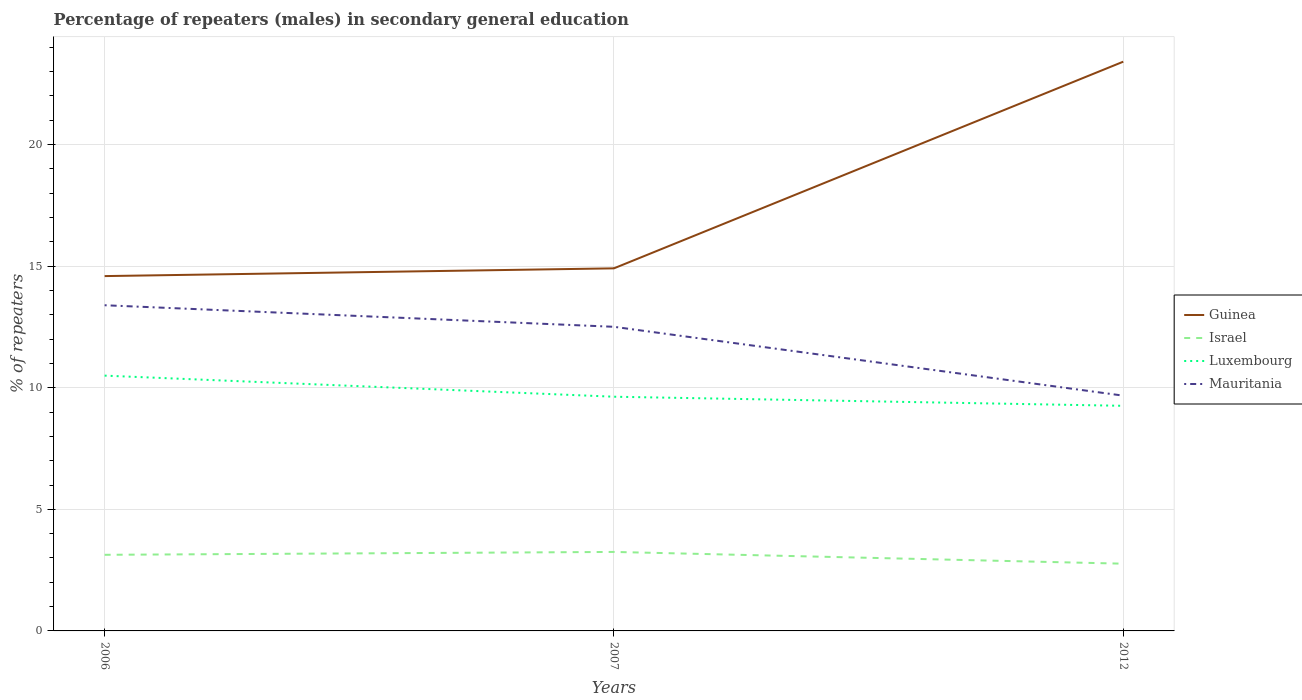Does the line corresponding to Guinea intersect with the line corresponding to Luxembourg?
Give a very brief answer. No. Is the number of lines equal to the number of legend labels?
Offer a terse response. Yes. Across all years, what is the maximum percentage of male repeaters in Luxembourg?
Your answer should be very brief. 9.26. What is the total percentage of male repeaters in Israel in the graph?
Offer a terse response. 0.36. What is the difference between the highest and the second highest percentage of male repeaters in Luxembourg?
Offer a very short reply. 1.24. What is the difference between the highest and the lowest percentage of male repeaters in Israel?
Your answer should be compact. 2. How many years are there in the graph?
Keep it short and to the point. 3. What is the difference between two consecutive major ticks on the Y-axis?
Your answer should be compact. 5. Are the values on the major ticks of Y-axis written in scientific E-notation?
Offer a very short reply. No. Does the graph contain any zero values?
Your response must be concise. No. How many legend labels are there?
Keep it short and to the point. 4. How are the legend labels stacked?
Offer a terse response. Vertical. What is the title of the graph?
Make the answer very short. Percentage of repeaters (males) in secondary general education. Does "Fragile and conflict affected situations" appear as one of the legend labels in the graph?
Your response must be concise. No. What is the label or title of the Y-axis?
Your answer should be compact. % of repeaters. What is the % of repeaters of Guinea in 2006?
Give a very brief answer. 14.59. What is the % of repeaters in Israel in 2006?
Provide a short and direct response. 3.13. What is the % of repeaters in Luxembourg in 2006?
Your answer should be compact. 10.5. What is the % of repeaters in Mauritania in 2006?
Your answer should be very brief. 13.39. What is the % of repeaters of Guinea in 2007?
Make the answer very short. 14.91. What is the % of repeaters of Israel in 2007?
Your answer should be compact. 3.25. What is the % of repeaters of Luxembourg in 2007?
Your answer should be compact. 9.63. What is the % of repeaters in Mauritania in 2007?
Offer a terse response. 12.51. What is the % of repeaters in Guinea in 2012?
Provide a succinct answer. 23.41. What is the % of repeaters in Israel in 2012?
Offer a terse response. 2.77. What is the % of repeaters in Luxembourg in 2012?
Provide a short and direct response. 9.26. What is the % of repeaters of Mauritania in 2012?
Ensure brevity in your answer.  9.68. Across all years, what is the maximum % of repeaters of Guinea?
Provide a succinct answer. 23.41. Across all years, what is the maximum % of repeaters of Israel?
Ensure brevity in your answer.  3.25. Across all years, what is the maximum % of repeaters of Luxembourg?
Keep it short and to the point. 10.5. Across all years, what is the maximum % of repeaters in Mauritania?
Provide a succinct answer. 13.39. Across all years, what is the minimum % of repeaters of Guinea?
Provide a short and direct response. 14.59. Across all years, what is the minimum % of repeaters of Israel?
Offer a terse response. 2.77. Across all years, what is the minimum % of repeaters in Luxembourg?
Offer a very short reply. 9.26. Across all years, what is the minimum % of repeaters of Mauritania?
Your answer should be very brief. 9.68. What is the total % of repeaters of Guinea in the graph?
Offer a terse response. 52.91. What is the total % of repeaters of Israel in the graph?
Your answer should be compact. 9.14. What is the total % of repeaters in Luxembourg in the graph?
Keep it short and to the point. 29.39. What is the total % of repeaters of Mauritania in the graph?
Your response must be concise. 35.58. What is the difference between the % of repeaters in Guinea in 2006 and that in 2007?
Keep it short and to the point. -0.32. What is the difference between the % of repeaters of Israel in 2006 and that in 2007?
Keep it short and to the point. -0.12. What is the difference between the % of repeaters in Luxembourg in 2006 and that in 2007?
Make the answer very short. 0.87. What is the difference between the % of repeaters in Mauritania in 2006 and that in 2007?
Provide a succinct answer. 0.89. What is the difference between the % of repeaters in Guinea in 2006 and that in 2012?
Offer a terse response. -8.82. What is the difference between the % of repeaters in Israel in 2006 and that in 2012?
Offer a terse response. 0.36. What is the difference between the % of repeaters in Luxembourg in 2006 and that in 2012?
Offer a very short reply. 1.24. What is the difference between the % of repeaters in Mauritania in 2006 and that in 2012?
Make the answer very short. 3.72. What is the difference between the % of repeaters in Guinea in 2007 and that in 2012?
Keep it short and to the point. -8.5. What is the difference between the % of repeaters in Israel in 2007 and that in 2012?
Provide a succinct answer. 0.48. What is the difference between the % of repeaters of Luxembourg in 2007 and that in 2012?
Give a very brief answer. 0.37. What is the difference between the % of repeaters of Mauritania in 2007 and that in 2012?
Make the answer very short. 2.83. What is the difference between the % of repeaters in Guinea in 2006 and the % of repeaters in Israel in 2007?
Offer a very short reply. 11.34. What is the difference between the % of repeaters of Guinea in 2006 and the % of repeaters of Luxembourg in 2007?
Your response must be concise. 4.96. What is the difference between the % of repeaters in Guinea in 2006 and the % of repeaters in Mauritania in 2007?
Ensure brevity in your answer.  2.09. What is the difference between the % of repeaters in Israel in 2006 and the % of repeaters in Luxembourg in 2007?
Give a very brief answer. -6.5. What is the difference between the % of repeaters of Israel in 2006 and the % of repeaters of Mauritania in 2007?
Offer a terse response. -9.38. What is the difference between the % of repeaters of Luxembourg in 2006 and the % of repeaters of Mauritania in 2007?
Offer a very short reply. -2.01. What is the difference between the % of repeaters in Guinea in 2006 and the % of repeaters in Israel in 2012?
Provide a succinct answer. 11.83. What is the difference between the % of repeaters of Guinea in 2006 and the % of repeaters of Luxembourg in 2012?
Offer a terse response. 5.33. What is the difference between the % of repeaters of Guinea in 2006 and the % of repeaters of Mauritania in 2012?
Give a very brief answer. 4.92. What is the difference between the % of repeaters in Israel in 2006 and the % of repeaters in Luxembourg in 2012?
Give a very brief answer. -6.13. What is the difference between the % of repeaters in Israel in 2006 and the % of repeaters in Mauritania in 2012?
Provide a short and direct response. -6.55. What is the difference between the % of repeaters in Luxembourg in 2006 and the % of repeaters in Mauritania in 2012?
Ensure brevity in your answer.  0.82. What is the difference between the % of repeaters of Guinea in 2007 and the % of repeaters of Israel in 2012?
Ensure brevity in your answer.  12.15. What is the difference between the % of repeaters in Guinea in 2007 and the % of repeaters in Luxembourg in 2012?
Your answer should be very brief. 5.65. What is the difference between the % of repeaters of Guinea in 2007 and the % of repeaters of Mauritania in 2012?
Ensure brevity in your answer.  5.24. What is the difference between the % of repeaters in Israel in 2007 and the % of repeaters in Luxembourg in 2012?
Make the answer very short. -6.01. What is the difference between the % of repeaters of Israel in 2007 and the % of repeaters of Mauritania in 2012?
Your response must be concise. -6.43. What is the difference between the % of repeaters in Luxembourg in 2007 and the % of repeaters in Mauritania in 2012?
Provide a short and direct response. -0.04. What is the average % of repeaters of Guinea per year?
Your answer should be compact. 17.64. What is the average % of repeaters of Israel per year?
Provide a short and direct response. 3.05. What is the average % of repeaters of Luxembourg per year?
Your answer should be very brief. 9.8. What is the average % of repeaters in Mauritania per year?
Keep it short and to the point. 11.86. In the year 2006, what is the difference between the % of repeaters of Guinea and % of repeaters of Israel?
Offer a very short reply. 11.46. In the year 2006, what is the difference between the % of repeaters of Guinea and % of repeaters of Luxembourg?
Provide a short and direct response. 4.09. In the year 2006, what is the difference between the % of repeaters in Guinea and % of repeaters in Mauritania?
Give a very brief answer. 1.2. In the year 2006, what is the difference between the % of repeaters of Israel and % of repeaters of Luxembourg?
Provide a succinct answer. -7.37. In the year 2006, what is the difference between the % of repeaters of Israel and % of repeaters of Mauritania?
Provide a succinct answer. -10.26. In the year 2006, what is the difference between the % of repeaters in Luxembourg and % of repeaters in Mauritania?
Offer a very short reply. -2.89. In the year 2007, what is the difference between the % of repeaters of Guinea and % of repeaters of Israel?
Provide a short and direct response. 11.66. In the year 2007, what is the difference between the % of repeaters of Guinea and % of repeaters of Luxembourg?
Your answer should be compact. 5.28. In the year 2007, what is the difference between the % of repeaters of Guinea and % of repeaters of Mauritania?
Ensure brevity in your answer.  2.4. In the year 2007, what is the difference between the % of repeaters in Israel and % of repeaters in Luxembourg?
Give a very brief answer. -6.38. In the year 2007, what is the difference between the % of repeaters of Israel and % of repeaters of Mauritania?
Keep it short and to the point. -9.26. In the year 2007, what is the difference between the % of repeaters of Luxembourg and % of repeaters of Mauritania?
Your response must be concise. -2.88. In the year 2012, what is the difference between the % of repeaters of Guinea and % of repeaters of Israel?
Make the answer very short. 20.65. In the year 2012, what is the difference between the % of repeaters of Guinea and % of repeaters of Luxembourg?
Offer a very short reply. 14.15. In the year 2012, what is the difference between the % of repeaters of Guinea and % of repeaters of Mauritania?
Your response must be concise. 13.73. In the year 2012, what is the difference between the % of repeaters in Israel and % of repeaters in Luxembourg?
Keep it short and to the point. -6.49. In the year 2012, what is the difference between the % of repeaters of Israel and % of repeaters of Mauritania?
Offer a very short reply. -6.91. In the year 2012, what is the difference between the % of repeaters in Luxembourg and % of repeaters in Mauritania?
Offer a terse response. -0.42. What is the ratio of the % of repeaters of Guinea in 2006 to that in 2007?
Your answer should be very brief. 0.98. What is the ratio of the % of repeaters of Israel in 2006 to that in 2007?
Provide a succinct answer. 0.96. What is the ratio of the % of repeaters of Luxembourg in 2006 to that in 2007?
Provide a short and direct response. 1.09. What is the ratio of the % of repeaters in Mauritania in 2006 to that in 2007?
Your response must be concise. 1.07. What is the ratio of the % of repeaters in Guinea in 2006 to that in 2012?
Your answer should be very brief. 0.62. What is the ratio of the % of repeaters of Israel in 2006 to that in 2012?
Ensure brevity in your answer.  1.13. What is the ratio of the % of repeaters in Luxembourg in 2006 to that in 2012?
Offer a very short reply. 1.13. What is the ratio of the % of repeaters of Mauritania in 2006 to that in 2012?
Provide a succinct answer. 1.38. What is the ratio of the % of repeaters of Guinea in 2007 to that in 2012?
Your response must be concise. 0.64. What is the ratio of the % of repeaters in Israel in 2007 to that in 2012?
Your answer should be compact. 1.17. What is the ratio of the % of repeaters of Luxembourg in 2007 to that in 2012?
Offer a terse response. 1.04. What is the ratio of the % of repeaters of Mauritania in 2007 to that in 2012?
Make the answer very short. 1.29. What is the difference between the highest and the second highest % of repeaters of Guinea?
Offer a terse response. 8.5. What is the difference between the highest and the second highest % of repeaters of Israel?
Give a very brief answer. 0.12. What is the difference between the highest and the second highest % of repeaters of Luxembourg?
Provide a short and direct response. 0.87. What is the difference between the highest and the second highest % of repeaters in Mauritania?
Provide a succinct answer. 0.89. What is the difference between the highest and the lowest % of repeaters of Guinea?
Keep it short and to the point. 8.82. What is the difference between the highest and the lowest % of repeaters of Israel?
Your answer should be very brief. 0.48. What is the difference between the highest and the lowest % of repeaters in Luxembourg?
Make the answer very short. 1.24. What is the difference between the highest and the lowest % of repeaters in Mauritania?
Your response must be concise. 3.72. 